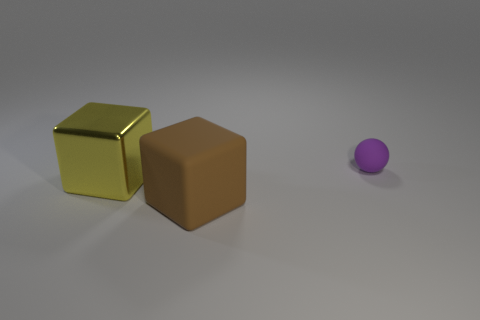Add 1 tiny purple matte things. How many objects exist? 4 Subtract all blocks. How many objects are left? 1 Subtract 0 brown balls. How many objects are left? 3 Subtract all brown objects. Subtract all tiny blue matte spheres. How many objects are left? 2 Add 1 small purple spheres. How many small purple spheres are left? 2 Add 1 purple things. How many purple things exist? 2 